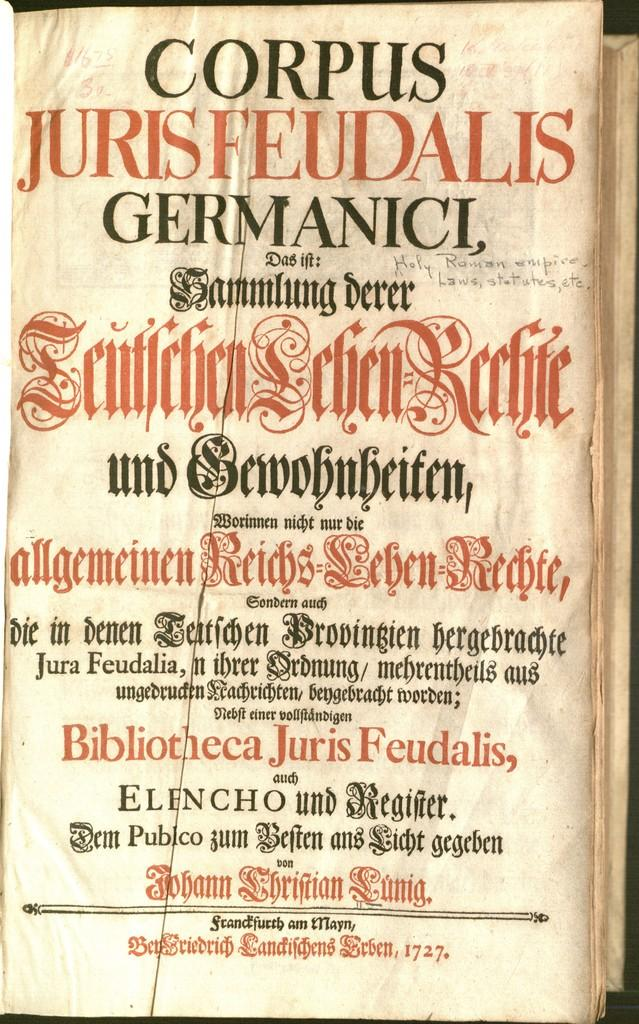Provide a one-sentence caption for the provided image. A page from an old book written in a foreign language and has Corpus Germanici in large black letters. 